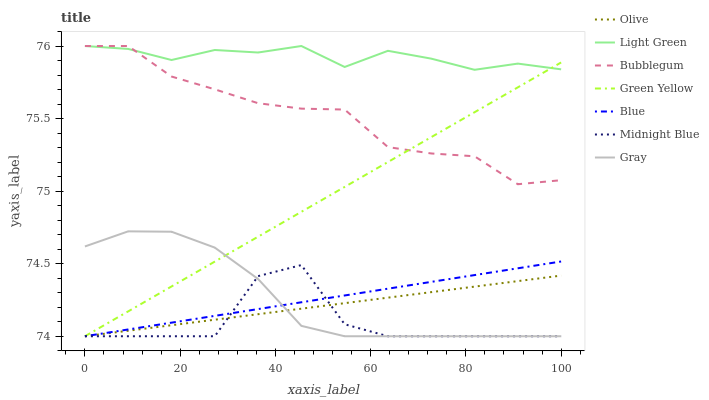Does Midnight Blue have the minimum area under the curve?
Answer yes or no. Yes. Does Light Green have the maximum area under the curve?
Answer yes or no. Yes. Does Gray have the minimum area under the curve?
Answer yes or no. No. Does Gray have the maximum area under the curve?
Answer yes or no. No. Is Green Yellow the smoothest?
Answer yes or no. Yes. Is Midnight Blue the roughest?
Answer yes or no. Yes. Is Gray the smoothest?
Answer yes or no. No. Is Gray the roughest?
Answer yes or no. No. Does Blue have the lowest value?
Answer yes or no. Yes. Does Bubblegum have the lowest value?
Answer yes or no. No. Does Light Green have the highest value?
Answer yes or no. Yes. Does Gray have the highest value?
Answer yes or no. No. Is Midnight Blue less than Light Green?
Answer yes or no. Yes. Is Bubblegum greater than Olive?
Answer yes or no. Yes. Does Blue intersect Olive?
Answer yes or no. Yes. Is Blue less than Olive?
Answer yes or no. No. Is Blue greater than Olive?
Answer yes or no. No. Does Midnight Blue intersect Light Green?
Answer yes or no. No. 